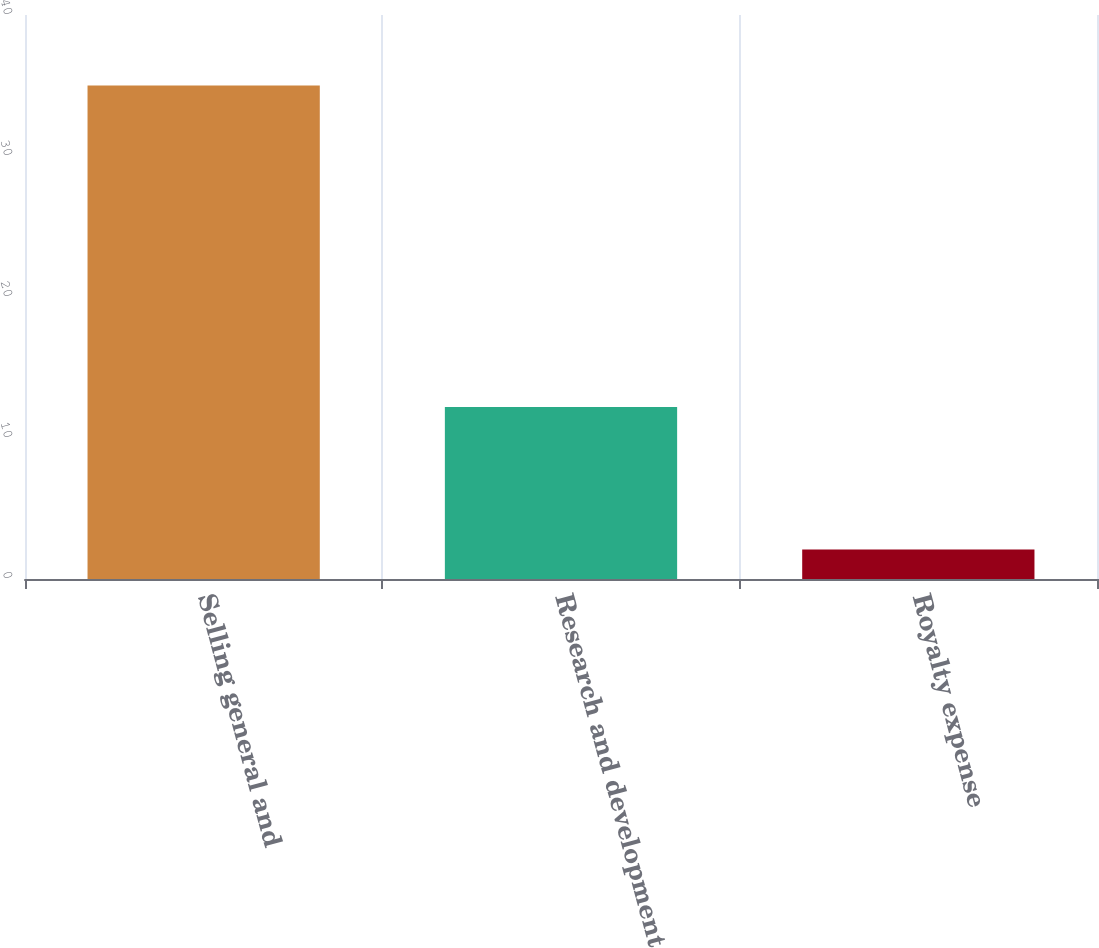Convert chart. <chart><loc_0><loc_0><loc_500><loc_500><bar_chart><fcel>Selling general and<fcel>Research and development<fcel>Royalty expense<nl><fcel>35<fcel>12.2<fcel>2.1<nl></chart> 